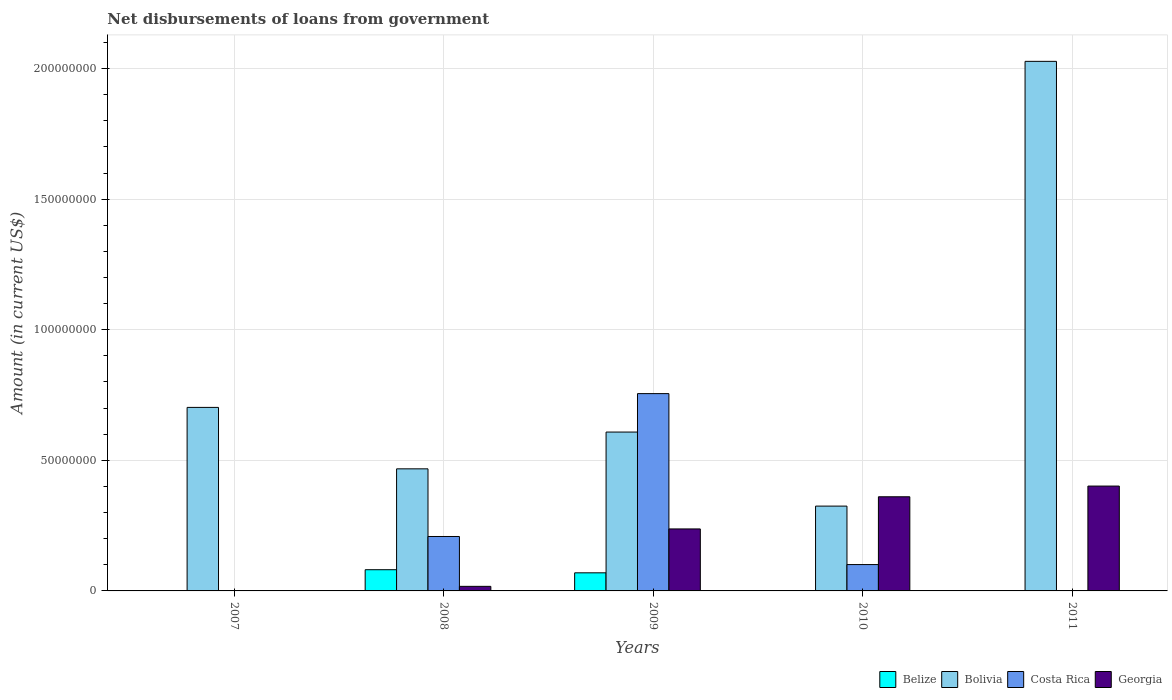Are the number of bars per tick equal to the number of legend labels?
Your answer should be very brief. No. Are the number of bars on each tick of the X-axis equal?
Your answer should be very brief. No. How many bars are there on the 2nd tick from the left?
Keep it short and to the point. 4. In how many cases, is the number of bars for a given year not equal to the number of legend labels?
Offer a very short reply. 3. What is the amount of loan disbursed from government in Bolivia in 2011?
Offer a terse response. 2.03e+08. Across all years, what is the maximum amount of loan disbursed from government in Georgia?
Make the answer very short. 4.01e+07. Across all years, what is the minimum amount of loan disbursed from government in Costa Rica?
Ensure brevity in your answer.  0. What is the total amount of loan disbursed from government in Costa Rica in the graph?
Your answer should be very brief. 1.06e+08. What is the difference between the amount of loan disbursed from government in Georgia in 2009 and that in 2011?
Provide a short and direct response. -1.64e+07. What is the difference between the amount of loan disbursed from government in Costa Rica in 2007 and the amount of loan disbursed from government in Bolivia in 2008?
Give a very brief answer. -4.68e+07. What is the average amount of loan disbursed from government in Bolivia per year?
Provide a short and direct response. 8.26e+07. In the year 2011, what is the difference between the amount of loan disbursed from government in Georgia and amount of loan disbursed from government in Bolivia?
Provide a succinct answer. -1.63e+08. In how many years, is the amount of loan disbursed from government in Belize greater than 30000000 US$?
Keep it short and to the point. 0. What is the ratio of the amount of loan disbursed from government in Bolivia in 2009 to that in 2010?
Offer a very short reply. 1.87. Is the difference between the amount of loan disbursed from government in Georgia in 2009 and 2011 greater than the difference between the amount of loan disbursed from government in Bolivia in 2009 and 2011?
Ensure brevity in your answer.  Yes. What is the difference between the highest and the second highest amount of loan disbursed from government in Georgia?
Offer a terse response. 4.10e+06. What is the difference between the highest and the lowest amount of loan disbursed from government in Georgia?
Your answer should be very brief. 4.01e+07. Is it the case that in every year, the sum of the amount of loan disbursed from government in Costa Rica and amount of loan disbursed from government in Bolivia is greater than the sum of amount of loan disbursed from government in Belize and amount of loan disbursed from government in Georgia?
Give a very brief answer. No. Is it the case that in every year, the sum of the amount of loan disbursed from government in Georgia and amount of loan disbursed from government in Belize is greater than the amount of loan disbursed from government in Costa Rica?
Offer a very short reply. No. How many bars are there?
Your answer should be very brief. 14. Are all the bars in the graph horizontal?
Offer a terse response. No. How many years are there in the graph?
Provide a succinct answer. 5. Are the values on the major ticks of Y-axis written in scientific E-notation?
Give a very brief answer. No. Does the graph contain any zero values?
Offer a very short reply. Yes. Does the graph contain grids?
Your answer should be compact. Yes. Where does the legend appear in the graph?
Make the answer very short. Bottom right. How many legend labels are there?
Provide a short and direct response. 4. What is the title of the graph?
Your answer should be compact. Net disbursements of loans from government. Does "Vietnam" appear as one of the legend labels in the graph?
Offer a terse response. No. What is the label or title of the X-axis?
Offer a terse response. Years. What is the Amount (in current US$) in Belize in 2007?
Your response must be concise. 0. What is the Amount (in current US$) of Bolivia in 2007?
Keep it short and to the point. 7.03e+07. What is the Amount (in current US$) in Belize in 2008?
Provide a succinct answer. 8.12e+06. What is the Amount (in current US$) in Bolivia in 2008?
Give a very brief answer. 4.68e+07. What is the Amount (in current US$) of Costa Rica in 2008?
Provide a succinct answer. 2.08e+07. What is the Amount (in current US$) of Georgia in 2008?
Your answer should be compact. 1.75e+06. What is the Amount (in current US$) in Belize in 2009?
Give a very brief answer. 6.93e+06. What is the Amount (in current US$) of Bolivia in 2009?
Your answer should be very brief. 6.08e+07. What is the Amount (in current US$) of Costa Rica in 2009?
Provide a succinct answer. 7.56e+07. What is the Amount (in current US$) in Georgia in 2009?
Make the answer very short. 2.37e+07. What is the Amount (in current US$) in Belize in 2010?
Your answer should be compact. 0. What is the Amount (in current US$) in Bolivia in 2010?
Ensure brevity in your answer.  3.25e+07. What is the Amount (in current US$) of Costa Rica in 2010?
Provide a succinct answer. 1.01e+07. What is the Amount (in current US$) of Georgia in 2010?
Give a very brief answer. 3.61e+07. What is the Amount (in current US$) in Belize in 2011?
Offer a very short reply. 0. What is the Amount (in current US$) of Bolivia in 2011?
Ensure brevity in your answer.  2.03e+08. What is the Amount (in current US$) of Costa Rica in 2011?
Your answer should be compact. 0. What is the Amount (in current US$) of Georgia in 2011?
Give a very brief answer. 4.01e+07. Across all years, what is the maximum Amount (in current US$) in Belize?
Keep it short and to the point. 8.12e+06. Across all years, what is the maximum Amount (in current US$) in Bolivia?
Keep it short and to the point. 2.03e+08. Across all years, what is the maximum Amount (in current US$) of Costa Rica?
Your answer should be compact. 7.56e+07. Across all years, what is the maximum Amount (in current US$) in Georgia?
Provide a succinct answer. 4.01e+07. Across all years, what is the minimum Amount (in current US$) in Bolivia?
Your answer should be compact. 3.25e+07. Across all years, what is the minimum Amount (in current US$) in Costa Rica?
Your answer should be very brief. 0. What is the total Amount (in current US$) in Belize in the graph?
Ensure brevity in your answer.  1.50e+07. What is the total Amount (in current US$) of Bolivia in the graph?
Keep it short and to the point. 4.13e+08. What is the total Amount (in current US$) of Costa Rica in the graph?
Offer a very short reply. 1.06e+08. What is the total Amount (in current US$) of Georgia in the graph?
Your response must be concise. 1.02e+08. What is the difference between the Amount (in current US$) of Bolivia in 2007 and that in 2008?
Make the answer very short. 2.35e+07. What is the difference between the Amount (in current US$) in Bolivia in 2007 and that in 2009?
Offer a terse response. 9.44e+06. What is the difference between the Amount (in current US$) in Bolivia in 2007 and that in 2010?
Offer a very short reply. 3.78e+07. What is the difference between the Amount (in current US$) of Bolivia in 2007 and that in 2011?
Provide a succinct answer. -1.33e+08. What is the difference between the Amount (in current US$) of Belize in 2008 and that in 2009?
Your answer should be very brief. 1.19e+06. What is the difference between the Amount (in current US$) of Bolivia in 2008 and that in 2009?
Your answer should be compact. -1.41e+07. What is the difference between the Amount (in current US$) in Costa Rica in 2008 and that in 2009?
Give a very brief answer. -5.47e+07. What is the difference between the Amount (in current US$) in Georgia in 2008 and that in 2009?
Offer a very short reply. -2.20e+07. What is the difference between the Amount (in current US$) of Bolivia in 2008 and that in 2010?
Offer a very short reply. 1.43e+07. What is the difference between the Amount (in current US$) of Costa Rica in 2008 and that in 2010?
Make the answer very short. 1.08e+07. What is the difference between the Amount (in current US$) in Georgia in 2008 and that in 2010?
Provide a succinct answer. -3.43e+07. What is the difference between the Amount (in current US$) in Bolivia in 2008 and that in 2011?
Keep it short and to the point. -1.56e+08. What is the difference between the Amount (in current US$) in Georgia in 2008 and that in 2011?
Your answer should be compact. -3.84e+07. What is the difference between the Amount (in current US$) of Bolivia in 2009 and that in 2010?
Ensure brevity in your answer.  2.84e+07. What is the difference between the Amount (in current US$) in Costa Rica in 2009 and that in 2010?
Your answer should be very brief. 6.55e+07. What is the difference between the Amount (in current US$) of Georgia in 2009 and that in 2010?
Keep it short and to the point. -1.23e+07. What is the difference between the Amount (in current US$) of Bolivia in 2009 and that in 2011?
Offer a very short reply. -1.42e+08. What is the difference between the Amount (in current US$) in Georgia in 2009 and that in 2011?
Offer a terse response. -1.64e+07. What is the difference between the Amount (in current US$) of Bolivia in 2010 and that in 2011?
Ensure brevity in your answer.  -1.70e+08. What is the difference between the Amount (in current US$) of Georgia in 2010 and that in 2011?
Your answer should be compact. -4.10e+06. What is the difference between the Amount (in current US$) of Bolivia in 2007 and the Amount (in current US$) of Costa Rica in 2008?
Offer a terse response. 4.94e+07. What is the difference between the Amount (in current US$) of Bolivia in 2007 and the Amount (in current US$) of Georgia in 2008?
Offer a very short reply. 6.85e+07. What is the difference between the Amount (in current US$) of Bolivia in 2007 and the Amount (in current US$) of Costa Rica in 2009?
Give a very brief answer. -5.28e+06. What is the difference between the Amount (in current US$) of Bolivia in 2007 and the Amount (in current US$) of Georgia in 2009?
Ensure brevity in your answer.  4.65e+07. What is the difference between the Amount (in current US$) in Bolivia in 2007 and the Amount (in current US$) in Costa Rica in 2010?
Make the answer very short. 6.02e+07. What is the difference between the Amount (in current US$) in Bolivia in 2007 and the Amount (in current US$) in Georgia in 2010?
Offer a terse response. 3.42e+07. What is the difference between the Amount (in current US$) in Bolivia in 2007 and the Amount (in current US$) in Georgia in 2011?
Offer a very short reply. 3.01e+07. What is the difference between the Amount (in current US$) of Belize in 2008 and the Amount (in current US$) of Bolivia in 2009?
Offer a very short reply. -5.27e+07. What is the difference between the Amount (in current US$) in Belize in 2008 and the Amount (in current US$) in Costa Rica in 2009?
Offer a terse response. -6.74e+07. What is the difference between the Amount (in current US$) of Belize in 2008 and the Amount (in current US$) of Georgia in 2009?
Your answer should be compact. -1.56e+07. What is the difference between the Amount (in current US$) of Bolivia in 2008 and the Amount (in current US$) of Costa Rica in 2009?
Your response must be concise. -2.88e+07. What is the difference between the Amount (in current US$) in Bolivia in 2008 and the Amount (in current US$) in Georgia in 2009?
Make the answer very short. 2.30e+07. What is the difference between the Amount (in current US$) of Costa Rica in 2008 and the Amount (in current US$) of Georgia in 2009?
Make the answer very short. -2.90e+06. What is the difference between the Amount (in current US$) of Belize in 2008 and the Amount (in current US$) of Bolivia in 2010?
Ensure brevity in your answer.  -2.44e+07. What is the difference between the Amount (in current US$) in Belize in 2008 and the Amount (in current US$) in Costa Rica in 2010?
Your answer should be compact. -1.97e+06. What is the difference between the Amount (in current US$) of Belize in 2008 and the Amount (in current US$) of Georgia in 2010?
Offer a terse response. -2.79e+07. What is the difference between the Amount (in current US$) of Bolivia in 2008 and the Amount (in current US$) of Costa Rica in 2010?
Provide a short and direct response. 3.67e+07. What is the difference between the Amount (in current US$) in Bolivia in 2008 and the Amount (in current US$) in Georgia in 2010?
Your answer should be compact. 1.07e+07. What is the difference between the Amount (in current US$) in Costa Rica in 2008 and the Amount (in current US$) in Georgia in 2010?
Your answer should be compact. -1.52e+07. What is the difference between the Amount (in current US$) of Belize in 2008 and the Amount (in current US$) of Bolivia in 2011?
Ensure brevity in your answer.  -1.95e+08. What is the difference between the Amount (in current US$) in Belize in 2008 and the Amount (in current US$) in Georgia in 2011?
Offer a terse response. -3.20e+07. What is the difference between the Amount (in current US$) in Bolivia in 2008 and the Amount (in current US$) in Georgia in 2011?
Provide a succinct answer. 6.60e+06. What is the difference between the Amount (in current US$) of Costa Rica in 2008 and the Amount (in current US$) of Georgia in 2011?
Keep it short and to the point. -1.93e+07. What is the difference between the Amount (in current US$) of Belize in 2009 and the Amount (in current US$) of Bolivia in 2010?
Your answer should be compact. -2.55e+07. What is the difference between the Amount (in current US$) of Belize in 2009 and the Amount (in current US$) of Costa Rica in 2010?
Provide a short and direct response. -3.16e+06. What is the difference between the Amount (in current US$) in Belize in 2009 and the Amount (in current US$) in Georgia in 2010?
Your answer should be compact. -2.91e+07. What is the difference between the Amount (in current US$) in Bolivia in 2009 and the Amount (in current US$) in Costa Rica in 2010?
Your response must be concise. 5.07e+07. What is the difference between the Amount (in current US$) of Bolivia in 2009 and the Amount (in current US$) of Georgia in 2010?
Keep it short and to the point. 2.48e+07. What is the difference between the Amount (in current US$) in Costa Rica in 2009 and the Amount (in current US$) in Georgia in 2010?
Provide a short and direct response. 3.95e+07. What is the difference between the Amount (in current US$) of Belize in 2009 and the Amount (in current US$) of Bolivia in 2011?
Your answer should be compact. -1.96e+08. What is the difference between the Amount (in current US$) in Belize in 2009 and the Amount (in current US$) in Georgia in 2011?
Your answer should be very brief. -3.32e+07. What is the difference between the Amount (in current US$) of Bolivia in 2009 and the Amount (in current US$) of Georgia in 2011?
Provide a short and direct response. 2.07e+07. What is the difference between the Amount (in current US$) in Costa Rica in 2009 and the Amount (in current US$) in Georgia in 2011?
Give a very brief answer. 3.54e+07. What is the difference between the Amount (in current US$) in Bolivia in 2010 and the Amount (in current US$) in Georgia in 2011?
Make the answer very short. -7.67e+06. What is the difference between the Amount (in current US$) of Costa Rica in 2010 and the Amount (in current US$) of Georgia in 2011?
Your answer should be very brief. -3.01e+07. What is the average Amount (in current US$) in Belize per year?
Your answer should be compact. 3.01e+06. What is the average Amount (in current US$) in Bolivia per year?
Provide a short and direct response. 8.26e+07. What is the average Amount (in current US$) in Costa Rica per year?
Provide a succinct answer. 2.13e+07. What is the average Amount (in current US$) in Georgia per year?
Provide a succinct answer. 2.03e+07. In the year 2008, what is the difference between the Amount (in current US$) in Belize and Amount (in current US$) in Bolivia?
Your answer should be compact. -3.86e+07. In the year 2008, what is the difference between the Amount (in current US$) of Belize and Amount (in current US$) of Costa Rica?
Provide a short and direct response. -1.27e+07. In the year 2008, what is the difference between the Amount (in current US$) of Belize and Amount (in current US$) of Georgia?
Offer a terse response. 6.37e+06. In the year 2008, what is the difference between the Amount (in current US$) in Bolivia and Amount (in current US$) in Costa Rica?
Make the answer very short. 2.59e+07. In the year 2008, what is the difference between the Amount (in current US$) of Bolivia and Amount (in current US$) of Georgia?
Your answer should be compact. 4.50e+07. In the year 2008, what is the difference between the Amount (in current US$) of Costa Rica and Amount (in current US$) of Georgia?
Provide a short and direct response. 1.91e+07. In the year 2009, what is the difference between the Amount (in current US$) of Belize and Amount (in current US$) of Bolivia?
Keep it short and to the point. -5.39e+07. In the year 2009, what is the difference between the Amount (in current US$) in Belize and Amount (in current US$) in Costa Rica?
Keep it short and to the point. -6.86e+07. In the year 2009, what is the difference between the Amount (in current US$) in Belize and Amount (in current US$) in Georgia?
Your response must be concise. -1.68e+07. In the year 2009, what is the difference between the Amount (in current US$) of Bolivia and Amount (in current US$) of Costa Rica?
Your answer should be very brief. -1.47e+07. In the year 2009, what is the difference between the Amount (in current US$) in Bolivia and Amount (in current US$) in Georgia?
Give a very brief answer. 3.71e+07. In the year 2009, what is the difference between the Amount (in current US$) in Costa Rica and Amount (in current US$) in Georgia?
Make the answer very short. 5.18e+07. In the year 2010, what is the difference between the Amount (in current US$) of Bolivia and Amount (in current US$) of Costa Rica?
Give a very brief answer. 2.24e+07. In the year 2010, what is the difference between the Amount (in current US$) in Bolivia and Amount (in current US$) in Georgia?
Give a very brief answer. -3.57e+06. In the year 2010, what is the difference between the Amount (in current US$) in Costa Rica and Amount (in current US$) in Georgia?
Your response must be concise. -2.60e+07. In the year 2011, what is the difference between the Amount (in current US$) of Bolivia and Amount (in current US$) of Georgia?
Offer a very short reply. 1.63e+08. What is the ratio of the Amount (in current US$) of Bolivia in 2007 to that in 2008?
Keep it short and to the point. 1.5. What is the ratio of the Amount (in current US$) in Bolivia in 2007 to that in 2009?
Offer a very short reply. 1.16. What is the ratio of the Amount (in current US$) in Bolivia in 2007 to that in 2010?
Your response must be concise. 2.16. What is the ratio of the Amount (in current US$) of Bolivia in 2007 to that in 2011?
Make the answer very short. 0.35. What is the ratio of the Amount (in current US$) in Belize in 2008 to that in 2009?
Your answer should be very brief. 1.17. What is the ratio of the Amount (in current US$) of Bolivia in 2008 to that in 2009?
Your answer should be compact. 0.77. What is the ratio of the Amount (in current US$) in Costa Rica in 2008 to that in 2009?
Ensure brevity in your answer.  0.28. What is the ratio of the Amount (in current US$) of Georgia in 2008 to that in 2009?
Your answer should be compact. 0.07. What is the ratio of the Amount (in current US$) of Bolivia in 2008 to that in 2010?
Offer a very short reply. 1.44. What is the ratio of the Amount (in current US$) of Costa Rica in 2008 to that in 2010?
Your response must be concise. 2.07. What is the ratio of the Amount (in current US$) of Georgia in 2008 to that in 2010?
Keep it short and to the point. 0.05. What is the ratio of the Amount (in current US$) of Bolivia in 2008 to that in 2011?
Your response must be concise. 0.23. What is the ratio of the Amount (in current US$) in Georgia in 2008 to that in 2011?
Make the answer very short. 0.04. What is the ratio of the Amount (in current US$) in Bolivia in 2009 to that in 2010?
Offer a terse response. 1.87. What is the ratio of the Amount (in current US$) of Costa Rica in 2009 to that in 2010?
Offer a very short reply. 7.49. What is the ratio of the Amount (in current US$) of Georgia in 2009 to that in 2010?
Ensure brevity in your answer.  0.66. What is the ratio of the Amount (in current US$) of Bolivia in 2009 to that in 2011?
Provide a succinct answer. 0.3. What is the ratio of the Amount (in current US$) of Georgia in 2009 to that in 2011?
Make the answer very short. 0.59. What is the ratio of the Amount (in current US$) in Bolivia in 2010 to that in 2011?
Your response must be concise. 0.16. What is the ratio of the Amount (in current US$) of Georgia in 2010 to that in 2011?
Ensure brevity in your answer.  0.9. What is the difference between the highest and the second highest Amount (in current US$) in Bolivia?
Provide a short and direct response. 1.33e+08. What is the difference between the highest and the second highest Amount (in current US$) in Costa Rica?
Offer a very short reply. 5.47e+07. What is the difference between the highest and the second highest Amount (in current US$) of Georgia?
Provide a succinct answer. 4.10e+06. What is the difference between the highest and the lowest Amount (in current US$) of Belize?
Your answer should be very brief. 8.12e+06. What is the difference between the highest and the lowest Amount (in current US$) of Bolivia?
Offer a very short reply. 1.70e+08. What is the difference between the highest and the lowest Amount (in current US$) of Costa Rica?
Keep it short and to the point. 7.56e+07. What is the difference between the highest and the lowest Amount (in current US$) in Georgia?
Ensure brevity in your answer.  4.01e+07. 